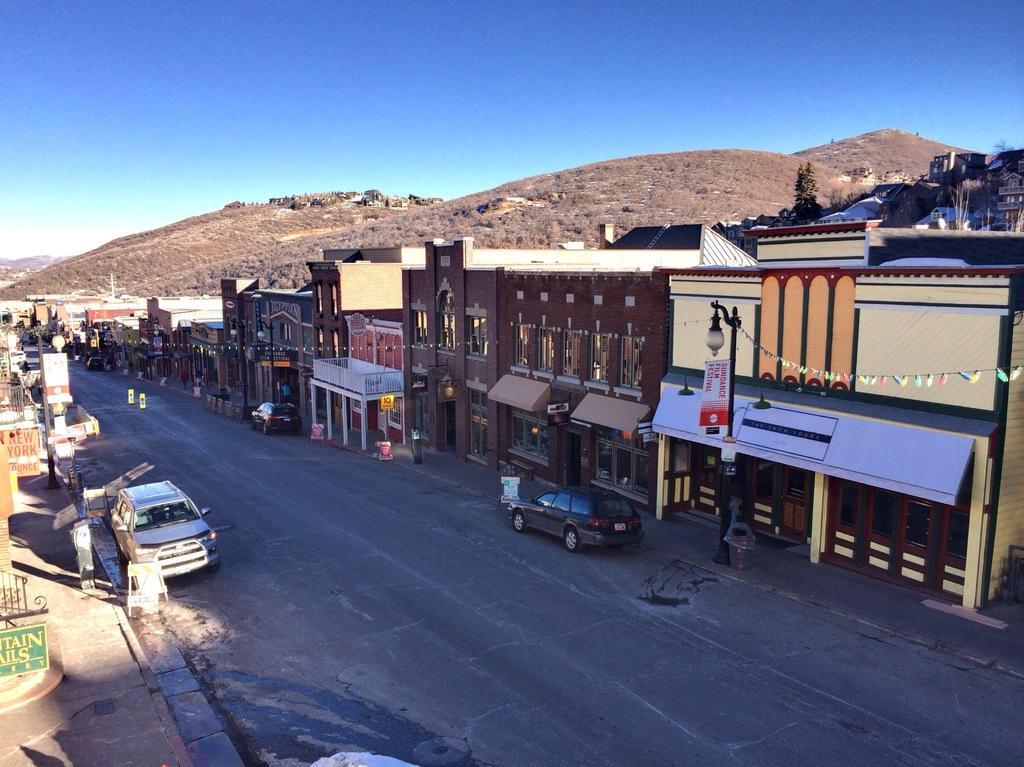In one or two sentences, can you explain what this image depicts? In this picture we can see many buildings. At the bottom there are two cars on the road, beside that we can see the street lights, poles and other objects. In the background we can see mountain. At the top there is a sky. 